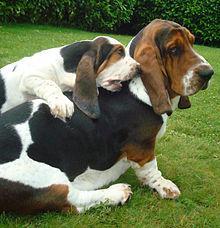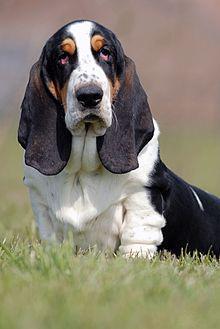The first image is the image on the left, the second image is the image on the right. Considering the images on both sides, is "There are at least three dogs outside in the grass." valid? Answer yes or no. Yes. The first image is the image on the left, the second image is the image on the right. Considering the images on both sides, is "An image shows at least one camera-facing basset hound sitting upright in the grass." valid? Answer yes or no. Yes. 